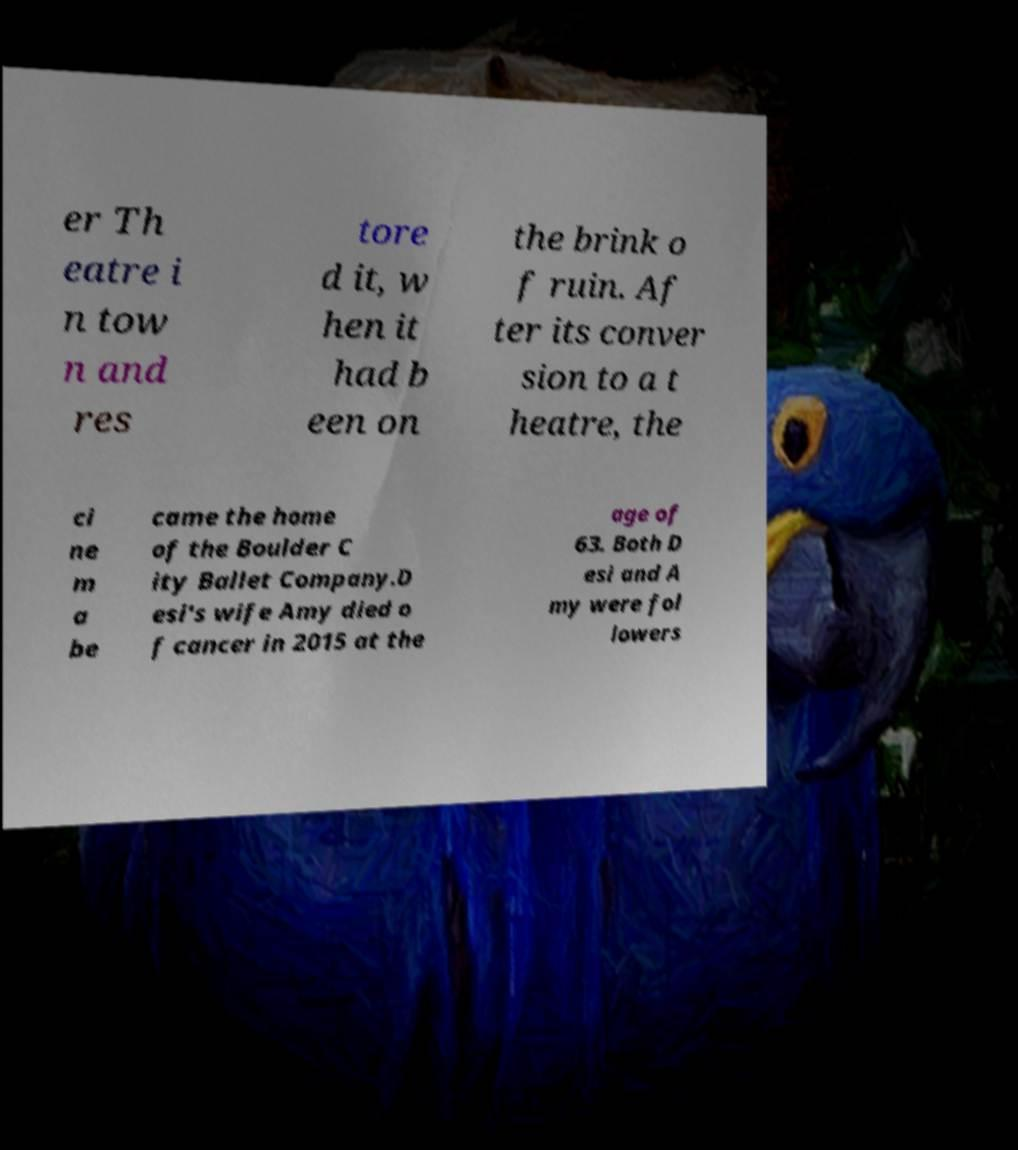There's text embedded in this image that I need extracted. Can you transcribe it verbatim? er Th eatre i n tow n and res tore d it, w hen it had b een on the brink o f ruin. Af ter its conver sion to a t heatre, the ci ne m a be came the home of the Boulder C ity Ballet Company.D esi's wife Amy died o f cancer in 2015 at the age of 63. Both D esi and A my were fol lowers 